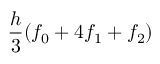Convert formula to latex. <formula><loc_0><loc_0><loc_500><loc_500>{ \frac { h } { 3 } } ( f _ { 0 } + 4 f _ { 1 } + f _ { 2 } )</formula> 